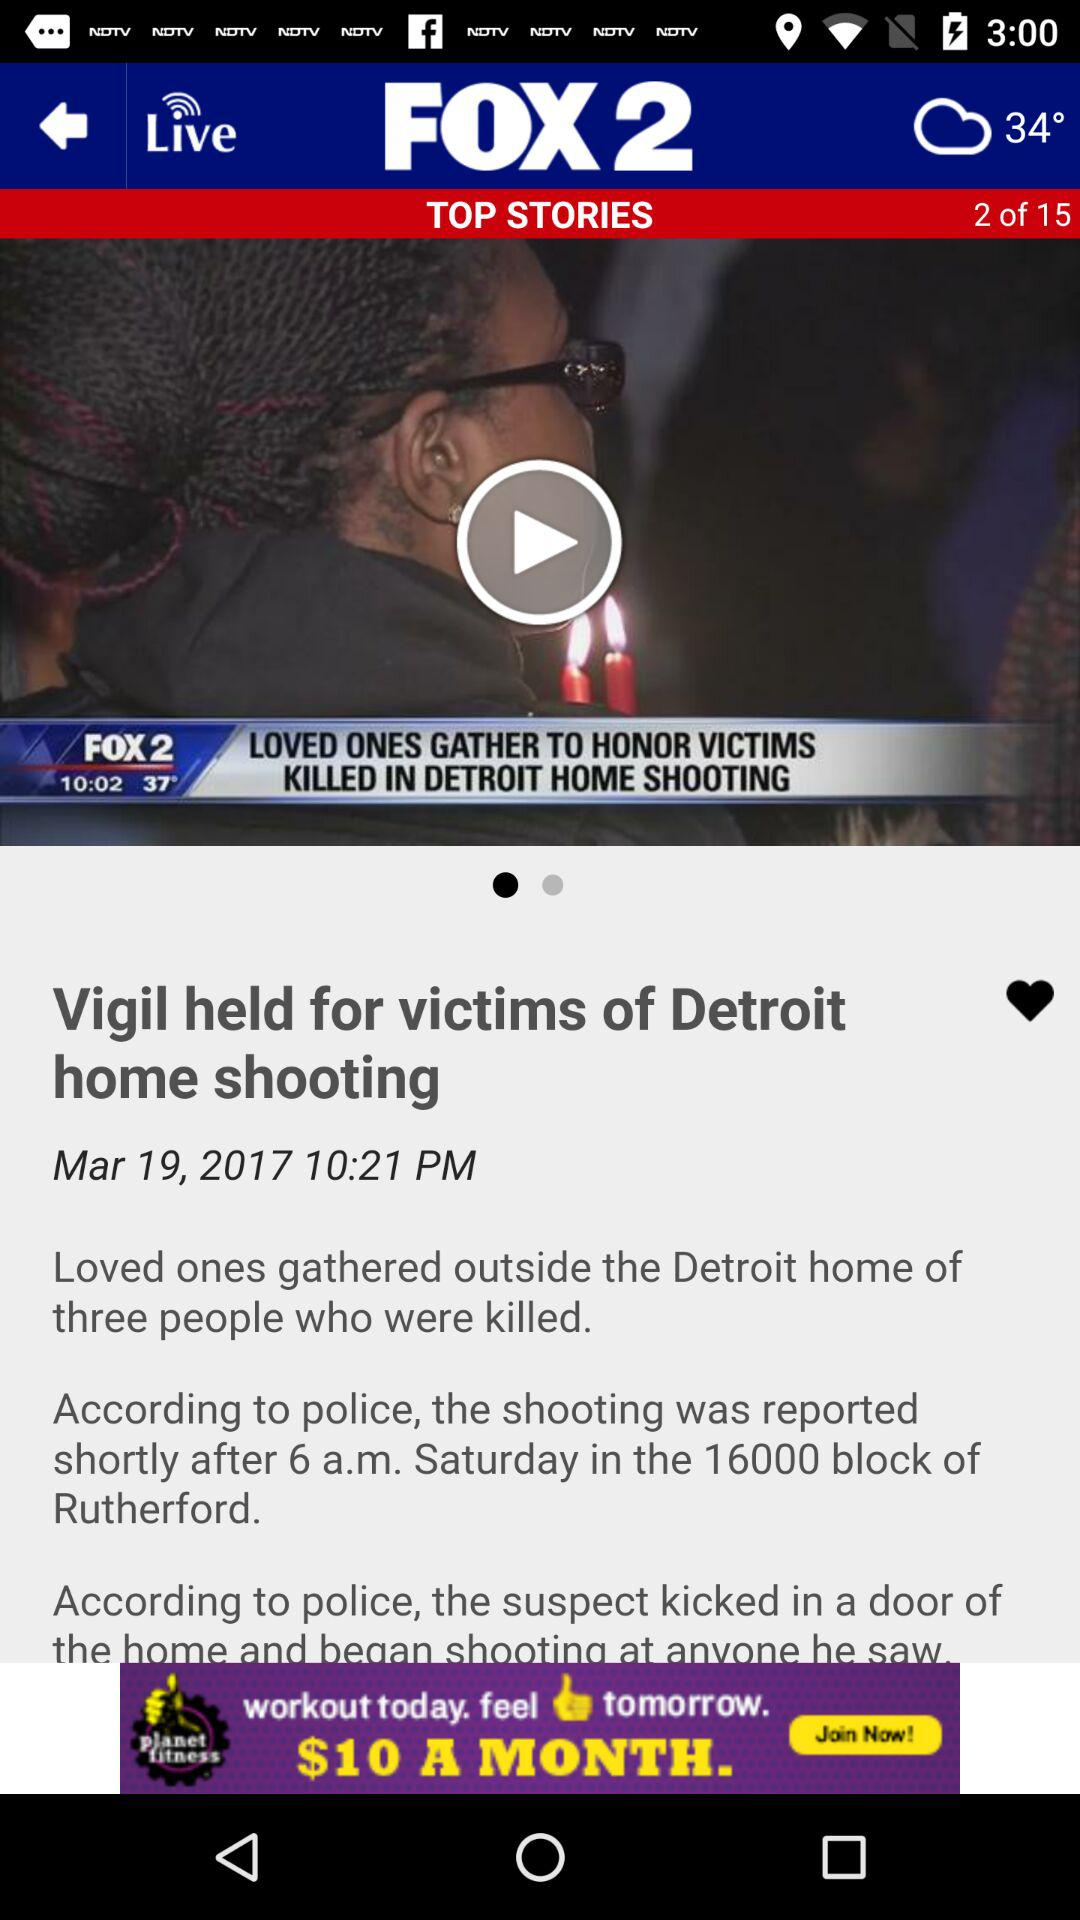How many total top stories are there? There are 15 top stories. 